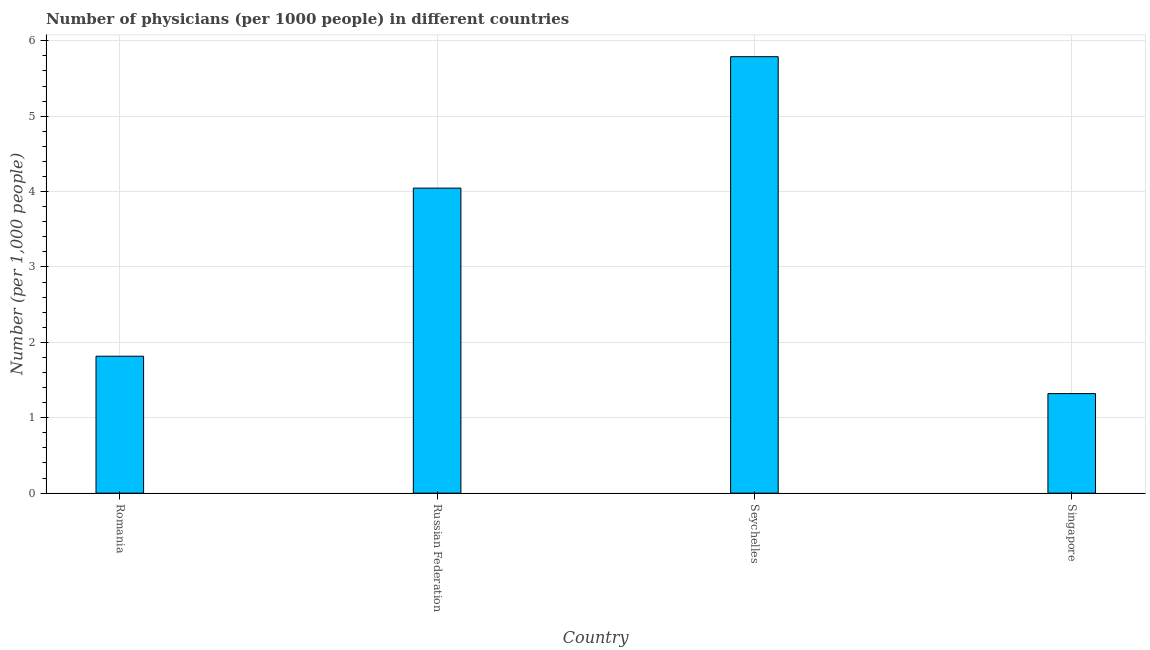Does the graph contain grids?
Offer a terse response. Yes. What is the title of the graph?
Offer a very short reply. Number of physicians (per 1000 people) in different countries. What is the label or title of the Y-axis?
Provide a succinct answer. Number (per 1,0 people). What is the number of physicians in Seychelles?
Keep it short and to the point. 5.79. Across all countries, what is the maximum number of physicians?
Make the answer very short. 5.79. Across all countries, what is the minimum number of physicians?
Provide a succinct answer. 1.32. In which country was the number of physicians maximum?
Ensure brevity in your answer.  Seychelles. In which country was the number of physicians minimum?
Ensure brevity in your answer.  Singapore. What is the sum of the number of physicians?
Your answer should be very brief. 12.97. What is the difference between the number of physicians in Romania and Seychelles?
Give a very brief answer. -3.97. What is the average number of physicians per country?
Your response must be concise. 3.24. What is the median number of physicians?
Offer a very short reply. 2.93. In how many countries, is the number of physicians greater than 1.2 ?
Keep it short and to the point. 4. What is the ratio of the number of physicians in Romania to that in Russian Federation?
Your answer should be very brief. 0.45. Is the difference between the number of physicians in Romania and Russian Federation greater than the difference between any two countries?
Keep it short and to the point. No. What is the difference between the highest and the second highest number of physicians?
Your response must be concise. 1.74. Is the sum of the number of physicians in Romania and Singapore greater than the maximum number of physicians across all countries?
Offer a terse response. No. What is the difference between the highest and the lowest number of physicians?
Ensure brevity in your answer.  4.47. In how many countries, is the number of physicians greater than the average number of physicians taken over all countries?
Provide a succinct answer. 2. How many bars are there?
Keep it short and to the point. 4. How many countries are there in the graph?
Your response must be concise. 4. Are the values on the major ticks of Y-axis written in scientific E-notation?
Your response must be concise. No. What is the Number (per 1,000 people) in Romania?
Your response must be concise. 1.82. What is the Number (per 1,000 people) in Russian Federation?
Make the answer very short. 4.05. What is the Number (per 1,000 people) of Seychelles?
Your answer should be compact. 5.79. What is the Number (per 1,000 people) in Singapore?
Give a very brief answer. 1.32. What is the difference between the Number (per 1,000 people) in Romania and Russian Federation?
Ensure brevity in your answer.  -2.23. What is the difference between the Number (per 1,000 people) in Romania and Seychelles?
Provide a succinct answer. -3.97. What is the difference between the Number (per 1,000 people) in Romania and Singapore?
Offer a terse response. 0.5. What is the difference between the Number (per 1,000 people) in Russian Federation and Seychelles?
Your answer should be compact. -1.74. What is the difference between the Number (per 1,000 people) in Russian Federation and Singapore?
Provide a short and direct response. 2.73. What is the difference between the Number (per 1,000 people) in Seychelles and Singapore?
Provide a short and direct response. 4.47. What is the ratio of the Number (per 1,000 people) in Romania to that in Russian Federation?
Your response must be concise. 0.45. What is the ratio of the Number (per 1,000 people) in Romania to that in Seychelles?
Your answer should be very brief. 0.31. What is the ratio of the Number (per 1,000 people) in Romania to that in Singapore?
Keep it short and to the point. 1.38. What is the ratio of the Number (per 1,000 people) in Russian Federation to that in Seychelles?
Your response must be concise. 0.7. What is the ratio of the Number (per 1,000 people) in Russian Federation to that in Singapore?
Give a very brief answer. 3.06. What is the ratio of the Number (per 1,000 people) in Seychelles to that in Singapore?
Make the answer very short. 4.38. 